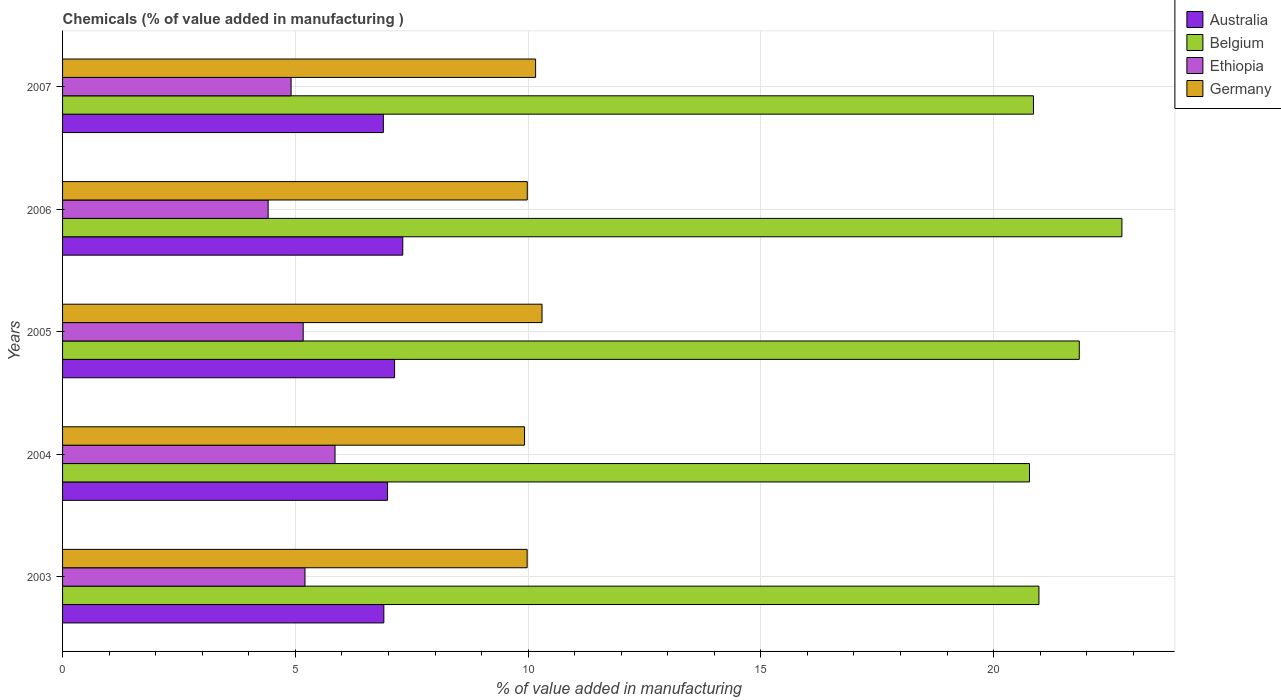How many bars are there on the 3rd tick from the top?
Your response must be concise. 4. What is the value added in manufacturing chemicals in Australia in 2004?
Offer a very short reply. 6.98. Across all years, what is the maximum value added in manufacturing chemicals in Ethiopia?
Offer a very short reply. 5.85. Across all years, what is the minimum value added in manufacturing chemicals in Germany?
Your answer should be compact. 9.92. In which year was the value added in manufacturing chemicals in Ethiopia maximum?
Your response must be concise. 2004. In which year was the value added in manufacturing chemicals in Australia minimum?
Make the answer very short. 2007. What is the total value added in manufacturing chemicals in Germany in the graph?
Your answer should be compact. 50.35. What is the difference between the value added in manufacturing chemicals in Australia in 2003 and that in 2007?
Keep it short and to the point. 0.01. What is the difference between the value added in manufacturing chemicals in Germany in 2004 and the value added in manufacturing chemicals in Australia in 2005?
Ensure brevity in your answer.  2.79. What is the average value added in manufacturing chemicals in Ethiopia per year?
Offer a terse response. 5.11. In the year 2005, what is the difference between the value added in manufacturing chemicals in Australia and value added in manufacturing chemicals in Belgium?
Your answer should be compact. -14.71. In how many years, is the value added in manufacturing chemicals in Germany greater than 2 %?
Ensure brevity in your answer.  5. What is the ratio of the value added in manufacturing chemicals in Australia in 2004 to that in 2007?
Give a very brief answer. 1.01. Is the difference between the value added in manufacturing chemicals in Australia in 2003 and 2005 greater than the difference between the value added in manufacturing chemicals in Belgium in 2003 and 2005?
Offer a very short reply. Yes. What is the difference between the highest and the second highest value added in manufacturing chemicals in Germany?
Your answer should be compact. 0.14. What is the difference between the highest and the lowest value added in manufacturing chemicals in Belgium?
Your answer should be very brief. 1.99. Is the sum of the value added in manufacturing chemicals in Germany in 2004 and 2005 greater than the maximum value added in manufacturing chemicals in Ethiopia across all years?
Offer a terse response. Yes. Is it the case that in every year, the sum of the value added in manufacturing chemicals in Australia and value added in manufacturing chemicals in Germany is greater than the sum of value added in manufacturing chemicals in Belgium and value added in manufacturing chemicals in Ethiopia?
Make the answer very short. No. What does the 2nd bar from the top in 2006 represents?
Keep it short and to the point. Ethiopia. What does the 2nd bar from the bottom in 2005 represents?
Offer a terse response. Belgium. Is it the case that in every year, the sum of the value added in manufacturing chemicals in Belgium and value added in manufacturing chemicals in Australia is greater than the value added in manufacturing chemicals in Germany?
Your response must be concise. Yes. What is the difference between two consecutive major ticks on the X-axis?
Keep it short and to the point. 5. Does the graph contain grids?
Your answer should be very brief. Yes. How many legend labels are there?
Your response must be concise. 4. How are the legend labels stacked?
Your response must be concise. Vertical. What is the title of the graph?
Your answer should be compact. Chemicals (% of value added in manufacturing ). What is the label or title of the X-axis?
Ensure brevity in your answer.  % of value added in manufacturing. What is the label or title of the Y-axis?
Make the answer very short. Years. What is the % of value added in manufacturing in Australia in 2003?
Provide a succinct answer. 6.9. What is the % of value added in manufacturing in Belgium in 2003?
Give a very brief answer. 20.97. What is the % of value added in manufacturing in Ethiopia in 2003?
Offer a very short reply. 5.21. What is the % of value added in manufacturing of Germany in 2003?
Your answer should be very brief. 9.98. What is the % of value added in manufacturing in Australia in 2004?
Keep it short and to the point. 6.98. What is the % of value added in manufacturing of Belgium in 2004?
Provide a succinct answer. 20.77. What is the % of value added in manufacturing of Ethiopia in 2004?
Make the answer very short. 5.85. What is the % of value added in manufacturing of Germany in 2004?
Provide a short and direct response. 9.92. What is the % of value added in manufacturing of Australia in 2005?
Offer a terse response. 7.13. What is the % of value added in manufacturing in Belgium in 2005?
Provide a short and direct response. 21.84. What is the % of value added in manufacturing of Ethiopia in 2005?
Keep it short and to the point. 5.17. What is the % of value added in manufacturing in Germany in 2005?
Your answer should be compact. 10.3. What is the % of value added in manufacturing in Australia in 2006?
Your answer should be compact. 7.31. What is the % of value added in manufacturing in Belgium in 2006?
Provide a short and direct response. 22.76. What is the % of value added in manufacturing in Ethiopia in 2006?
Keep it short and to the point. 4.42. What is the % of value added in manufacturing in Germany in 2006?
Ensure brevity in your answer.  9.98. What is the % of value added in manufacturing in Australia in 2007?
Your answer should be very brief. 6.89. What is the % of value added in manufacturing of Belgium in 2007?
Make the answer very short. 20.86. What is the % of value added in manufacturing in Ethiopia in 2007?
Provide a short and direct response. 4.91. What is the % of value added in manufacturing of Germany in 2007?
Provide a succinct answer. 10.16. Across all years, what is the maximum % of value added in manufacturing of Australia?
Your response must be concise. 7.31. Across all years, what is the maximum % of value added in manufacturing in Belgium?
Make the answer very short. 22.76. Across all years, what is the maximum % of value added in manufacturing of Ethiopia?
Offer a very short reply. 5.85. Across all years, what is the maximum % of value added in manufacturing of Germany?
Give a very brief answer. 10.3. Across all years, what is the minimum % of value added in manufacturing of Australia?
Ensure brevity in your answer.  6.89. Across all years, what is the minimum % of value added in manufacturing in Belgium?
Offer a very short reply. 20.77. Across all years, what is the minimum % of value added in manufacturing in Ethiopia?
Make the answer very short. 4.42. Across all years, what is the minimum % of value added in manufacturing in Germany?
Your response must be concise. 9.92. What is the total % of value added in manufacturing in Australia in the graph?
Ensure brevity in your answer.  35.21. What is the total % of value added in manufacturing in Belgium in the graph?
Your response must be concise. 107.19. What is the total % of value added in manufacturing of Ethiopia in the graph?
Make the answer very short. 25.55. What is the total % of value added in manufacturing of Germany in the graph?
Give a very brief answer. 50.35. What is the difference between the % of value added in manufacturing in Australia in 2003 and that in 2004?
Keep it short and to the point. -0.08. What is the difference between the % of value added in manufacturing of Belgium in 2003 and that in 2004?
Your response must be concise. 0.2. What is the difference between the % of value added in manufacturing in Ethiopia in 2003 and that in 2004?
Offer a terse response. -0.65. What is the difference between the % of value added in manufacturing of Germany in 2003 and that in 2004?
Your answer should be very brief. 0.06. What is the difference between the % of value added in manufacturing of Australia in 2003 and that in 2005?
Offer a very short reply. -0.23. What is the difference between the % of value added in manufacturing of Belgium in 2003 and that in 2005?
Provide a short and direct response. -0.87. What is the difference between the % of value added in manufacturing in Ethiopia in 2003 and that in 2005?
Provide a short and direct response. 0.04. What is the difference between the % of value added in manufacturing in Germany in 2003 and that in 2005?
Provide a succinct answer. -0.32. What is the difference between the % of value added in manufacturing in Australia in 2003 and that in 2006?
Offer a very short reply. -0.41. What is the difference between the % of value added in manufacturing in Belgium in 2003 and that in 2006?
Provide a short and direct response. -1.78. What is the difference between the % of value added in manufacturing of Ethiopia in 2003 and that in 2006?
Your answer should be compact. 0.79. What is the difference between the % of value added in manufacturing in Germany in 2003 and that in 2006?
Your answer should be compact. -0. What is the difference between the % of value added in manufacturing in Australia in 2003 and that in 2007?
Your response must be concise. 0.01. What is the difference between the % of value added in manufacturing in Belgium in 2003 and that in 2007?
Offer a very short reply. 0.12. What is the difference between the % of value added in manufacturing of Ethiopia in 2003 and that in 2007?
Provide a succinct answer. 0.3. What is the difference between the % of value added in manufacturing of Germany in 2003 and that in 2007?
Ensure brevity in your answer.  -0.18. What is the difference between the % of value added in manufacturing in Australia in 2004 and that in 2005?
Make the answer very short. -0.15. What is the difference between the % of value added in manufacturing of Belgium in 2004 and that in 2005?
Provide a short and direct response. -1.07. What is the difference between the % of value added in manufacturing of Ethiopia in 2004 and that in 2005?
Your response must be concise. 0.68. What is the difference between the % of value added in manufacturing in Germany in 2004 and that in 2005?
Provide a succinct answer. -0.38. What is the difference between the % of value added in manufacturing in Australia in 2004 and that in 2006?
Provide a succinct answer. -0.33. What is the difference between the % of value added in manufacturing of Belgium in 2004 and that in 2006?
Offer a terse response. -1.99. What is the difference between the % of value added in manufacturing of Ethiopia in 2004 and that in 2006?
Keep it short and to the point. 1.44. What is the difference between the % of value added in manufacturing in Germany in 2004 and that in 2006?
Offer a very short reply. -0.06. What is the difference between the % of value added in manufacturing of Australia in 2004 and that in 2007?
Give a very brief answer. 0.09. What is the difference between the % of value added in manufacturing in Belgium in 2004 and that in 2007?
Your response must be concise. -0.09. What is the difference between the % of value added in manufacturing of Ethiopia in 2004 and that in 2007?
Make the answer very short. 0.94. What is the difference between the % of value added in manufacturing of Germany in 2004 and that in 2007?
Give a very brief answer. -0.24. What is the difference between the % of value added in manufacturing of Australia in 2005 and that in 2006?
Give a very brief answer. -0.18. What is the difference between the % of value added in manufacturing in Belgium in 2005 and that in 2006?
Offer a very short reply. -0.92. What is the difference between the % of value added in manufacturing in Ethiopia in 2005 and that in 2006?
Provide a succinct answer. 0.75. What is the difference between the % of value added in manufacturing in Germany in 2005 and that in 2006?
Ensure brevity in your answer.  0.32. What is the difference between the % of value added in manufacturing in Australia in 2005 and that in 2007?
Keep it short and to the point. 0.24. What is the difference between the % of value added in manufacturing of Belgium in 2005 and that in 2007?
Ensure brevity in your answer.  0.98. What is the difference between the % of value added in manufacturing in Ethiopia in 2005 and that in 2007?
Give a very brief answer. 0.26. What is the difference between the % of value added in manufacturing in Germany in 2005 and that in 2007?
Offer a very short reply. 0.14. What is the difference between the % of value added in manufacturing in Australia in 2006 and that in 2007?
Your answer should be very brief. 0.42. What is the difference between the % of value added in manufacturing of Belgium in 2006 and that in 2007?
Your answer should be compact. 1.9. What is the difference between the % of value added in manufacturing in Ethiopia in 2006 and that in 2007?
Give a very brief answer. -0.49. What is the difference between the % of value added in manufacturing of Germany in 2006 and that in 2007?
Offer a terse response. -0.18. What is the difference between the % of value added in manufacturing of Australia in 2003 and the % of value added in manufacturing of Belgium in 2004?
Make the answer very short. -13.87. What is the difference between the % of value added in manufacturing in Australia in 2003 and the % of value added in manufacturing in Ethiopia in 2004?
Your response must be concise. 1.05. What is the difference between the % of value added in manufacturing in Australia in 2003 and the % of value added in manufacturing in Germany in 2004?
Your answer should be very brief. -3.02. What is the difference between the % of value added in manufacturing of Belgium in 2003 and the % of value added in manufacturing of Ethiopia in 2004?
Offer a terse response. 15.12. What is the difference between the % of value added in manufacturing of Belgium in 2003 and the % of value added in manufacturing of Germany in 2004?
Keep it short and to the point. 11.05. What is the difference between the % of value added in manufacturing of Ethiopia in 2003 and the % of value added in manufacturing of Germany in 2004?
Provide a short and direct response. -4.72. What is the difference between the % of value added in manufacturing in Australia in 2003 and the % of value added in manufacturing in Belgium in 2005?
Give a very brief answer. -14.94. What is the difference between the % of value added in manufacturing in Australia in 2003 and the % of value added in manufacturing in Ethiopia in 2005?
Ensure brevity in your answer.  1.73. What is the difference between the % of value added in manufacturing of Australia in 2003 and the % of value added in manufacturing of Germany in 2005?
Keep it short and to the point. -3.4. What is the difference between the % of value added in manufacturing of Belgium in 2003 and the % of value added in manufacturing of Ethiopia in 2005?
Give a very brief answer. 15.8. What is the difference between the % of value added in manufacturing of Belgium in 2003 and the % of value added in manufacturing of Germany in 2005?
Offer a very short reply. 10.67. What is the difference between the % of value added in manufacturing of Ethiopia in 2003 and the % of value added in manufacturing of Germany in 2005?
Make the answer very short. -5.09. What is the difference between the % of value added in manufacturing in Australia in 2003 and the % of value added in manufacturing in Belgium in 2006?
Provide a succinct answer. -15.85. What is the difference between the % of value added in manufacturing of Australia in 2003 and the % of value added in manufacturing of Ethiopia in 2006?
Provide a short and direct response. 2.49. What is the difference between the % of value added in manufacturing of Australia in 2003 and the % of value added in manufacturing of Germany in 2006?
Your answer should be very brief. -3.08. What is the difference between the % of value added in manufacturing in Belgium in 2003 and the % of value added in manufacturing in Ethiopia in 2006?
Your answer should be compact. 16.56. What is the difference between the % of value added in manufacturing in Belgium in 2003 and the % of value added in manufacturing in Germany in 2006?
Give a very brief answer. 10.99. What is the difference between the % of value added in manufacturing of Ethiopia in 2003 and the % of value added in manufacturing of Germany in 2006?
Your response must be concise. -4.78. What is the difference between the % of value added in manufacturing in Australia in 2003 and the % of value added in manufacturing in Belgium in 2007?
Offer a terse response. -13.95. What is the difference between the % of value added in manufacturing of Australia in 2003 and the % of value added in manufacturing of Ethiopia in 2007?
Keep it short and to the point. 1.99. What is the difference between the % of value added in manufacturing in Australia in 2003 and the % of value added in manufacturing in Germany in 2007?
Offer a very short reply. -3.26. What is the difference between the % of value added in manufacturing of Belgium in 2003 and the % of value added in manufacturing of Ethiopia in 2007?
Offer a terse response. 16.06. What is the difference between the % of value added in manufacturing in Belgium in 2003 and the % of value added in manufacturing in Germany in 2007?
Provide a short and direct response. 10.81. What is the difference between the % of value added in manufacturing of Ethiopia in 2003 and the % of value added in manufacturing of Germany in 2007?
Offer a very short reply. -4.95. What is the difference between the % of value added in manufacturing of Australia in 2004 and the % of value added in manufacturing of Belgium in 2005?
Your answer should be very brief. -14.86. What is the difference between the % of value added in manufacturing in Australia in 2004 and the % of value added in manufacturing in Ethiopia in 2005?
Offer a very short reply. 1.81. What is the difference between the % of value added in manufacturing of Australia in 2004 and the % of value added in manufacturing of Germany in 2005?
Ensure brevity in your answer.  -3.32. What is the difference between the % of value added in manufacturing of Belgium in 2004 and the % of value added in manufacturing of Ethiopia in 2005?
Provide a short and direct response. 15.6. What is the difference between the % of value added in manufacturing of Belgium in 2004 and the % of value added in manufacturing of Germany in 2005?
Ensure brevity in your answer.  10.47. What is the difference between the % of value added in manufacturing in Ethiopia in 2004 and the % of value added in manufacturing in Germany in 2005?
Provide a succinct answer. -4.45. What is the difference between the % of value added in manufacturing of Australia in 2004 and the % of value added in manufacturing of Belgium in 2006?
Provide a short and direct response. -15.78. What is the difference between the % of value added in manufacturing in Australia in 2004 and the % of value added in manufacturing in Ethiopia in 2006?
Give a very brief answer. 2.56. What is the difference between the % of value added in manufacturing of Australia in 2004 and the % of value added in manufacturing of Germany in 2006?
Your answer should be very brief. -3. What is the difference between the % of value added in manufacturing in Belgium in 2004 and the % of value added in manufacturing in Ethiopia in 2006?
Offer a very short reply. 16.35. What is the difference between the % of value added in manufacturing of Belgium in 2004 and the % of value added in manufacturing of Germany in 2006?
Make the answer very short. 10.79. What is the difference between the % of value added in manufacturing in Ethiopia in 2004 and the % of value added in manufacturing in Germany in 2006?
Your response must be concise. -4.13. What is the difference between the % of value added in manufacturing in Australia in 2004 and the % of value added in manufacturing in Belgium in 2007?
Provide a succinct answer. -13.88. What is the difference between the % of value added in manufacturing in Australia in 2004 and the % of value added in manufacturing in Ethiopia in 2007?
Ensure brevity in your answer.  2.07. What is the difference between the % of value added in manufacturing in Australia in 2004 and the % of value added in manufacturing in Germany in 2007?
Your answer should be very brief. -3.18. What is the difference between the % of value added in manufacturing of Belgium in 2004 and the % of value added in manufacturing of Ethiopia in 2007?
Your answer should be compact. 15.86. What is the difference between the % of value added in manufacturing in Belgium in 2004 and the % of value added in manufacturing in Germany in 2007?
Ensure brevity in your answer.  10.61. What is the difference between the % of value added in manufacturing in Ethiopia in 2004 and the % of value added in manufacturing in Germany in 2007?
Keep it short and to the point. -4.31. What is the difference between the % of value added in manufacturing of Australia in 2005 and the % of value added in manufacturing of Belgium in 2006?
Offer a very short reply. -15.62. What is the difference between the % of value added in manufacturing in Australia in 2005 and the % of value added in manufacturing in Ethiopia in 2006?
Your response must be concise. 2.72. What is the difference between the % of value added in manufacturing of Australia in 2005 and the % of value added in manufacturing of Germany in 2006?
Your answer should be compact. -2.85. What is the difference between the % of value added in manufacturing in Belgium in 2005 and the % of value added in manufacturing in Ethiopia in 2006?
Keep it short and to the point. 17.42. What is the difference between the % of value added in manufacturing in Belgium in 2005 and the % of value added in manufacturing in Germany in 2006?
Your answer should be very brief. 11.86. What is the difference between the % of value added in manufacturing in Ethiopia in 2005 and the % of value added in manufacturing in Germany in 2006?
Offer a very short reply. -4.81. What is the difference between the % of value added in manufacturing of Australia in 2005 and the % of value added in manufacturing of Belgium in 2007?
Ensure brevity in your answer.  -13.72. What is the difference between the % of value added in manufacturing in Australia in 2005 and the % of value added in manufacturing in Ethiopia in 2007?
Offer a terse response. 2.22. What is the difference between the % of value added in manufacturing of Australia in 2005 and the % of value added in manufacturing of Germany in 2007?
Offer a terse response. -3.03. What is the difference between the % of value added in manufacturing in Belgium in 2005 and the % of value added in manufacturing in Ethiopia in 2007?
Your response must be concise. 16.93. What is the difference between the % of value added in manufacturing in Belgium in 2005 and the % of value added in manufacturing in Germany in 2007?
Provide a short and direct response. 11.68. What is the difference between the % of value added in manufacturing in Ethiopia in 2005 and the % of value added in manufacturing in Germany in 2007?
Your answer should be compact. -4.99. What is the difference between the % of value added in manufacturing in Australia in 2006 and the % of value added in manufacturing in Belgium in 2007?
Provide a short and direct response. -13.55. What is the difference between the % of value added in manufacturing of Australia in 2006 and the % of value added in manufacturing of Ethiopia in 2007?
Make the answer very short. 2.4. What is the difference between the % of value added in manufacturing of Australia in 2006 and the % of value added in manufacturing of Germany in 2007?
Provide a succinct answer. -2.85. What is the difference between the % of value added in manufacturing of Belgium in 2006 and the % of value added in manufacturing of Ethiopia in 2007?
Provide a short and direct response. 17.85. What is the difference between the % of value added in manufacturing in Belgium in 2006 and the % of value added in manufacturing in Germany in 2007?
Your answer should be compact. 12.59. What is the difference between the % of value added in manufacturing in Ethiopia in 2006 and the % of value added in manufacturing in Germany in 2007?
Ensure brevity in your answer.  -5.75. What is the average % of value added in manufacturing of Australia per year?
Keep it short and to the point. 7.04. What is the average % of value added in manufacturing in Belgium per year?
Your answer should be compact. 21.44. What is the average % of value added in manufacturing in Ethiopia per year?
Provide a short and direct response. 5.11. What is the average % of value added in manufacturing of Germany per year?
Offer a very short reply. 10.07. In the year 2003, what is the difference between the % of value added in manufacturing of Australia and % of value added in manufacturing of Belgium?
Your answer should be compact. -14.07. In the year 2003, what is the difference between the % of value added in manufacturing of Australia and % of value added in manufacturing of Ethiopia?
Your response must be concise. 1.69. In the year 2003, what is the difference between the % of value added in manufacturing of Australia and % of value added in manufacturing of Germany?
Your answer should be compact. -3.08. In the year 2003, what is the difference between the % of value added in manufacturing in Belgium and % of value added in manufacturing in Ethiopia?
Provide a short and direct response. 15.77. In the year 2003, what is the difference between the % of value added in manufacturing in Belgium and % of value added in manufacturing in Germany?
Make the answer very short. 10.99. In the year 2003, what is the difference between the % of value added in manufacturing of Ethiopia and % of value added in manufacturing of Germany?
Keep it short and to the point. -4.77. In the year 2004, what is the difference between the % of value added in manufacturing in Australia and % of value added in manufacturing in Belgium?
Provide a short and direct response. -13.79. In the year 2004, what is the difference between the % of value added in manufacturing in Australia and % of value added in manufacturing in Ethiopia?
Your response must be concise. 1.13. In the year 2004, what is the difference between the % of value added in manufacturing in Australia and % of value added in manufacturing in Germany?
Provide a succinct answer. -2.94. In the year 2004, what is the difference between the % of value added in manufacturing in Belgium and % of value added in manufacturing in Ethiopia?
Your answer should be very brief. 14.92. In the year 2004, what is the difference between the % of value added in manufacturing in Belgium and % of value added in manufacturing in Germany?
Your response must be concise. 10.85. In the year 2004, what is the difference between the % of value added in manufacturing in Ethiopia and % of value added in manufacturing in Germany?
Your answer should be compact. -4.07. In the year 2005, what is the difference between the % of value added in manufacturing of Australia and % of value added in manufacturing of Belgium?
Give a very brief answer. -14.71. In the year 2005, what is the difference between the % of value added in manufacturing of Australia and % of value added in manufacturing of Ethiopia?
Provide a succinct answer. 1.96. In the year 2005, what is the difference between the % of value added in manufacturing in Australia and % of value added in manufacturing in Germany?
Your answer should be compact. -3.17. In the year 2005, what is the difference between the % of value added in manufacturing of Belgium and % of value added in manufacturing of Ethiopia?
Keep it short and to the point. 16.67. In the year 2005, what is the difference between the % of value added in manufacturing in Belgium and % of value added in manufacturing in Germany?
Offer a very short reply. 11.54. In the year 2005, what is the difference between the % of value added in manufacturing of Ethiopia and % of value added in manufacturing of Germany?
Give a very brief answer. -5.13. In the year 2006, what is the difference between the % of value added in manufacturing in Australia and % of value added in manufacturing in Belgium?
Ensure brevity in your answer.  -15.45. In the year 2006, what is the difference between the % of value added in manufacturing in Australia and % of value added in manufacturing in Ethiopia?
Provide a succinct answer. 2.89. In the year 2006, what is the difference between the % of value added in manufacturing in Australia and % of value added in manufacturing in Germany?
Keep it short and to the point. -2.67. In the year 2006, what is the difference between the % of value added in manufacturing of Belgium and % of value added in manufacturing of Ethiopia?
Keep it short and to the point. 18.34. In the year 2006, what is the difference between the % of value added in manufacturing of Belgium and % of value added in manufacturing of Germany?
Offer a very short reply. 12.77. In the year 2006, what is the difference between the % of value added in manufacturing in Ethiopia and % of value added in manufacturing in Germany?
Give a very brief answer. -5.57. In the year 2007, what is the difference between the % of value added in manufacturing in Australia and % of value added in manufacturing in Belgium?
Provide a succinct answer. -13.96. In the year 2007, what is the difference between the % of value added in manufacturing in Australia and % of value added in manufacturing in Ethiopia?
Give a very brief answer. 1.98. In the year 2007, what is the difference between the % of value added in manufacturing of Australia and % of value added in manufacturing of Germany?
Provide a short and direct response. -3.27. In the year 2007, what is the difference between the % of value added in manufacturing in Belgium and % of value added in manufacturing in Ethiopia?
Ensure brevity in your answer.  15.95. In the year 2007, what is the difference between the % of value added in manufacturing of Belgium and % of value added in manufacturing of Germany?
Offer a very short reply. 10.69. In the year 2007, what is the difference between the % of value added in manufacturing of Ethiopia and % of value added in manufacturing of Germany?
Your answer should be compact. -5.25. What is the ratio of the % of value added in manufacturing of Australia in 2003 to that in 2004?
Keep it short and to the point. 0.99. What is the ratio of the % of value added in manufacturing in Belgium in 2003 to that in 2004?
Provide a short and direct response. 1.01. What is the ratio of the % of value added in manufacturing in Ethiopia in 2003 to that in 2004?
Give a very brief answer. 0.89. What is the ratio of the % of value added in manufacturing in Germany in 2003 to that in 2004?
Your answer should be compact. 1.01. What is the ratio of the % of value added in manufacturing of Australia in 2003 to that in 2005?
Keep it short and to the point. 0.97. What is the ratio of the % of value added in manufacturing of Belgium in 2003 to that in 2005?
Offer a terse response. 0.96. What is the ratio of the % of value added in manufacturing in Ethiopia in 2003 to that in 2005?
Provide a succinct answer. 1.01. What is the ratio of the % of value added in manufacturing of Germany in 2003 to that in 2005?
Your answer should be very brief. 0.97. What is the ratio of the % of value added in manufacturing in Australia in 2003 to that in 2006?
Provide a succinct answer. 0.94. What is the ratio of the % of value added in manufacturing of Belgium in 2003 to that in 2006?
Give a very brief answer. 0.92. What is the ratio of the % of value added in manufacturing in Ethiopia in 2003 to that in 2006?
Keep it short and to the point. 1.18. What is the ratio of the % of value added in manufacturing in Germany in 2003 to that in 2006?
Provide a succinct answer. 1. What is the ratio of the % of value added in manufacturing of Belgium in 2003 to that in 2007?
Your answer should be compact. 1.01. What is the ratio of the % of value added in manufacturing in Ethiopia in 2003 to that in 2007?
Ensure brevity in your answer.  1.06. What is the ratio of the % of value added in manufacturing in Germany in 2003 to that in 2007?
Make the answer very short. 0.98. What is the ratio of the % of value added in manufacturing of Australia in 2004 to that in 2005?
Provide a short and direct response. 0.98. What is the ratio of the % of value added in manufacturing in Belgium in 2004 to that in 2005?
Your response must be concise. 0.95. What is the ratio of the % of value added in manufacturing in Ethiopia in 2004 to that in 2005?
Provide a short and direct response. 1.13. What is the ratio of the % of value added in manufacturing in Germany in 2004 to that in 2005?
Make the answer very short. 0.96. What is the ratio of the % of value added in manufacturing of Australia in 2004 to that in 2006?
Your answer should be very brief. 0.96. What is the ratio of the % of value added in manufacturing in Belgium in 2004 to that in 2006?
Your answer should be compact. 0.91. What is the ratio of the % of value added in manufacturing in Ethiopia in 2004 to that in 2006?
Your response must be concise. 1.33. What is the ratio of the % of value added in manufacturing in Australia in 2004 to that in 2007?
Ensure brevity in your answer.  1.01. What is the ratio of the % of value added in manufacturing in Belgium in 2004 to that in 2007?
Ensure brevity in your answer.  1. What is the ratio of the % of value added in manufacturing of Ethiopia in 2004 to that in 2007?
Provide a short and direct response. 1.19. What is the ratio of the % of value added in manufacturing in Germany in 2004 to that in 2007?
Ensure brevity in your answer.  0.98. What is the ratio of the % of value added in manufacturing in Australia in 2005 to that in 2006?
Make the answer very short. 0.98. What is the ratio of the % of value added in manufacturing in Belgium in 2005 to that in 2006?
Make the answer very short. 0.96. What is the ratio of the % of value added in manufacturing of Ethiopia in 2005 to that in 2006?
Give a very brief answer. 1.17. What is the ratio of the % of value added in manufacturing of Germany in 2005 to that in 2006?
Offer a terse response. 1.03. What is the ratio of the % of value added in manufacturing in Australia in 2005 to that in 2007?
Ensure brevity in your answer.  1.03. What is the ratio of the % of value added in manufacturing in Belgium in 2005 to that in 2007?
Offer a terse response. 1.05. What is the ratio of the % of value added in manufacturing of Ethiopia in 2005 to that in 2007?
Provide a succinct answer. 1.05. What is the ratio of the % of value added in manufacturing of Germany in 2005 to that in 2007?
Your response must be concise. 1.01. What is the ratio of the % of value added in manufacturing in Australia in 2006 to that in 2007?
Your response must be concise. 1.06. What is the ratio of the % of value added in manufacturing in Belgium in 2006 to that in 2007?
Make the answer very short. 1.09. What is the ratio of the % of value added in manufacturing in Ethiopia in 2006 to that in 2007?
Your answer should be compact. 0.9. What is the ratio of the % of value added in manufacturing in Germany in 2006 to that in 2007?
Your response must be concise. 0.98. What is the difference between the highest and the second highest % of value added in manufacturing of Australia?
Provide a short and direct response. 0.18. What is the difference between the highest and the second highest % of value added in manufacturing in Belgium?
Offer a terse response. 0.92. What is the difference between the highest and the second highest % of value added in manufacturing in Ethiopia?
Provide a succinct answer. 0.65. What is the difference between the highest and the second highest % of value added in manufacturing of Germany?
Make the answer very short. 0.14. What is the difference between the highest and the lowest % of value added in manufacturing of Australia?
Provide a succinct answer. 0.42. What is the difference between the highest and the lowest % of value added in manufacturing in Belgium?
Provide a short and direct response. 1.99. What is the difference between the highest and the lowest % of value added in manufacturing in Ethiopia?
Give a very brief answer. 1.44. What is the difference between the highest and the lowest % of value added in manufacturing in Germany?
Provide a short and direct response. 0.38. 